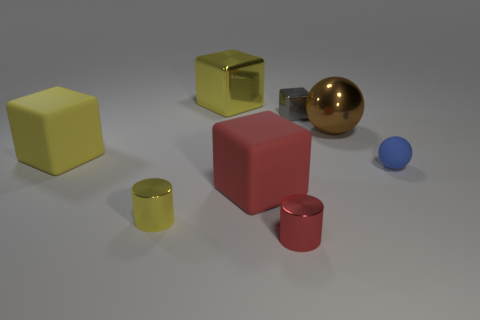There is a metal thing that is the same size as the brown metal sphere; what is its shape?
Provide a succinct answer. Cube. There is a big thing that is behind the large sphere; are there any big balls behind it?
Provide a succinct answer. No. What number of large things are yellow cubes or balls?
Offer a terse response. 3. Is there a gray thing of the same size as the red metal cylinder?
Offer a terse response. Yes. Is the number of big yellow metallic cubes the same as the number of purple cylinders?
Offer a terse response. No. What number of rubber things are tiny gray blocks or blue spheres?
Ensure brevity in your answer.  1. The shiny object that is the same color as the large metallic cube is what shape?
Make the answer very short. Cylinder. How many purple shiny objects are there?
Ensure brevity in your answer.  0. Is the material of the large yellow cube behind the tiny gray metal block the same as the tiny cylinder in front of the small yellow object?
Your response must be concise. Yes. What size is the yellow block that is the same material as the big sphere?
Ensure brevity in your answer.  Large. 